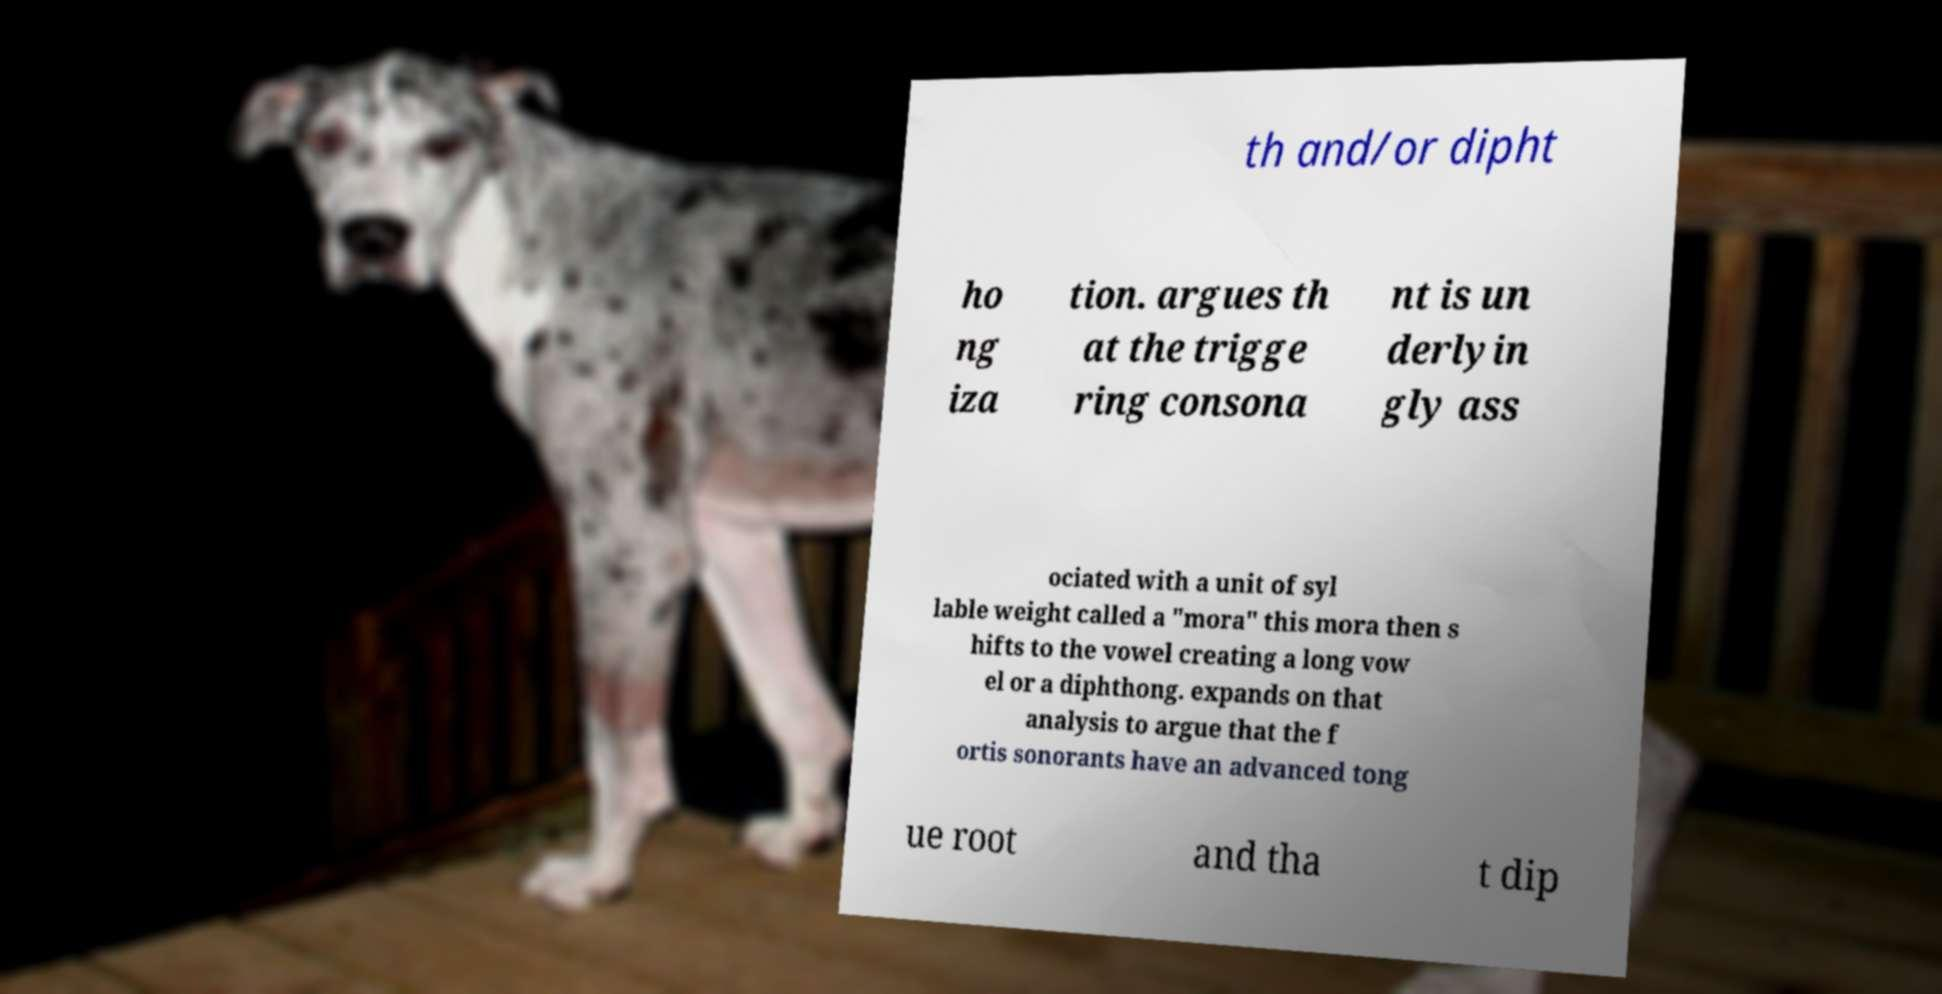Please read and relay the text visible in this image. What does it say? th and/or dipht ho ng iza tion. argues th at the trigge ring consona nt is un derlyin gly ass ociated with a unit of syl lable weight called a "mora" this mora then s hifts to the vowel creating a long vow el or a diphthong. expands on that analysis to argue that the f ortis sonorants have an advanced tong ue root and tha t dip 